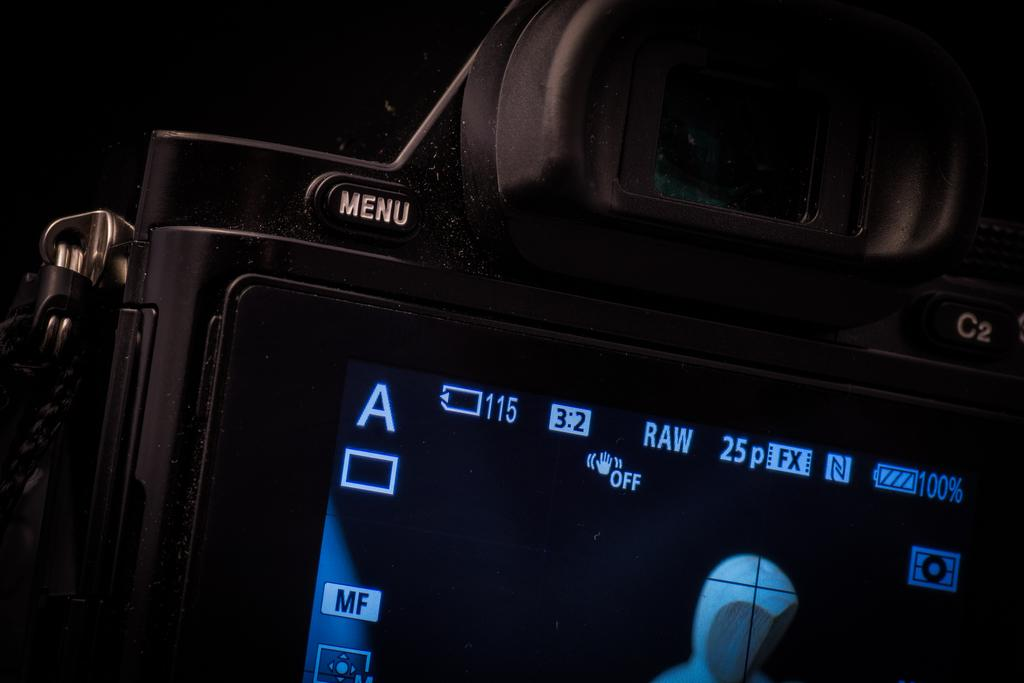What is the main subject of the image? The main subject of the image is a camera. Where is the camera located in the image? The camera is the center of the image. What can be seen on the camera? There is text written on the camera, and there is a screen displaying something in the camera. What type of loaf is being used to take a picture in the image? There is no loaf present in the image; it features a camera with a screen and text. Can you tell me how many toes are visible on the camera in the image? There are no toes visible on the camera in the image; it is an electronic device with a screen and text. 